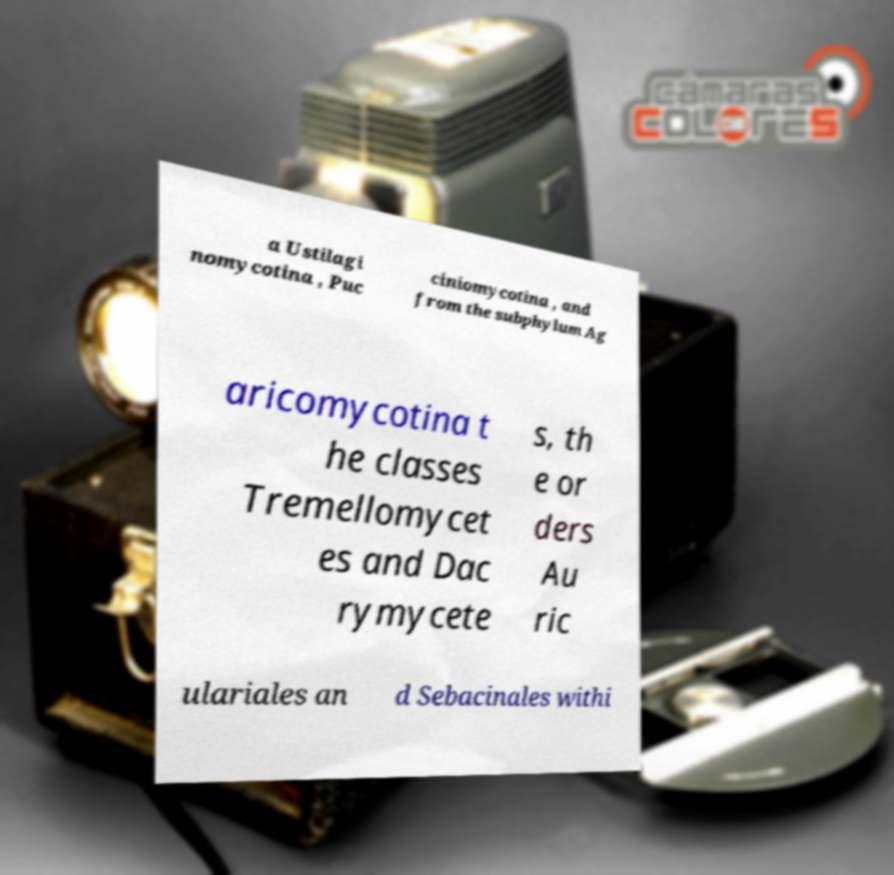There's text embedded in this image that I need extracted. Can you transcribe it verbatim? a Ustilagi nomycotina , Puc ciniomycotina , and from the subphylum Ag aricomycotina t he classes Tremellomycet es and Dac rymycete s, th e or ders Au ric ulariales an d Sebacinales withi 